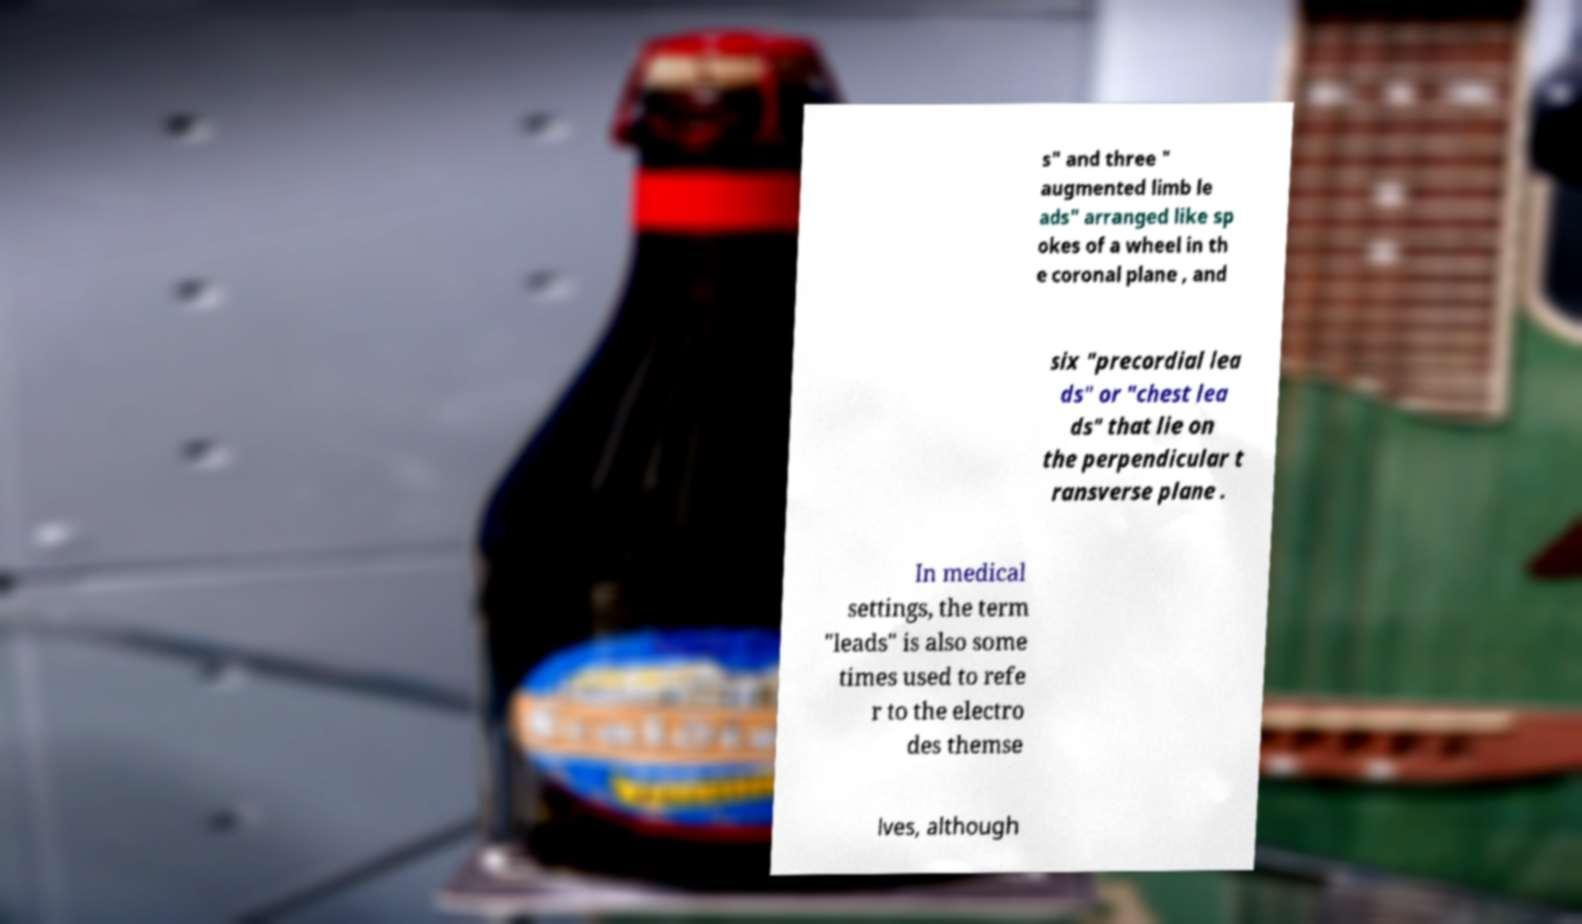What messages or text are displayed in this image? I need them in a readable, typed format. s" and three " augmented limb le ads" arranged like sp okes of a wheel in th e coronal plane , and six "precordial lea ds" or "chest lea ds" that lie on the perpendicular t ransverse plane . In medical settings, the term "leads" is also some times used to refe r to the electro des themse lves, although 